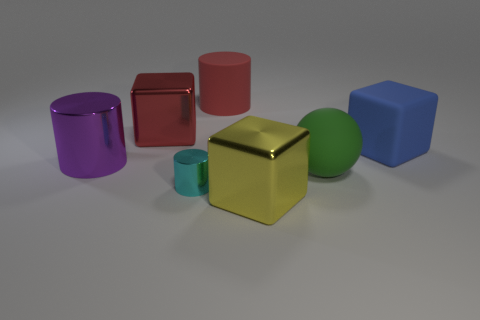Add 3 gray metal spheres. How many objects exist? 10 Subtract all cylinders. How many objects are left? 4 Subtract 0 red balls. How many objects are left? 7 Subtract all blue matte balls. Subtract all rubber cylinders. How many objects are left? 6 Add 1 big red things. How many big red things are left? 3 Add 2 yellow metallic blocks. How many yellow metallic blocks exist? 3 